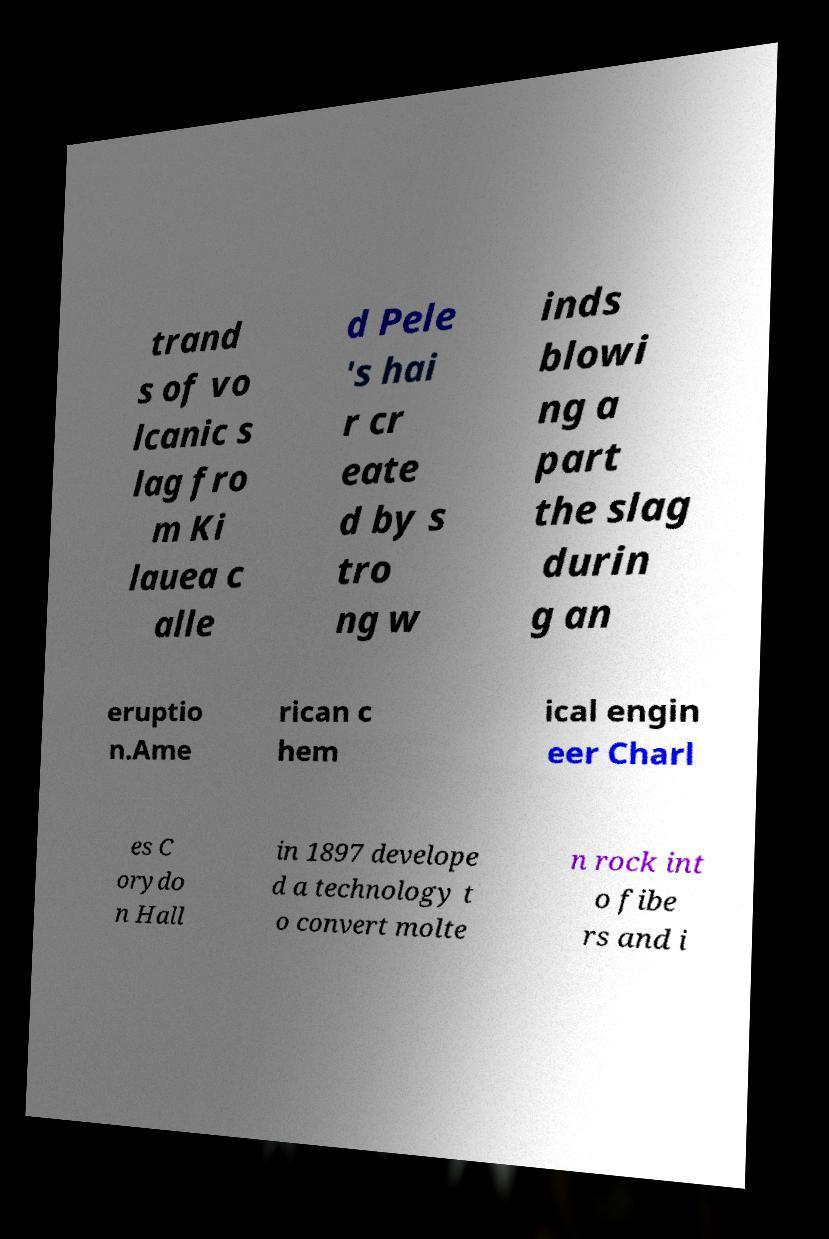What messages or text are displayed in this image? I need them in a readable, typed format. trand s of vo lcanic s lag fro m Ki lauea c alle d Pele 's hai r cr eate d by s tro ng w inds blowi ng a part the slag durin g an eruptio n.Ame rican c hem ical engin eer Charl es C orydo n Hall in 1897 develope d a technology t o convert molte n rock int o fibe rs and i 